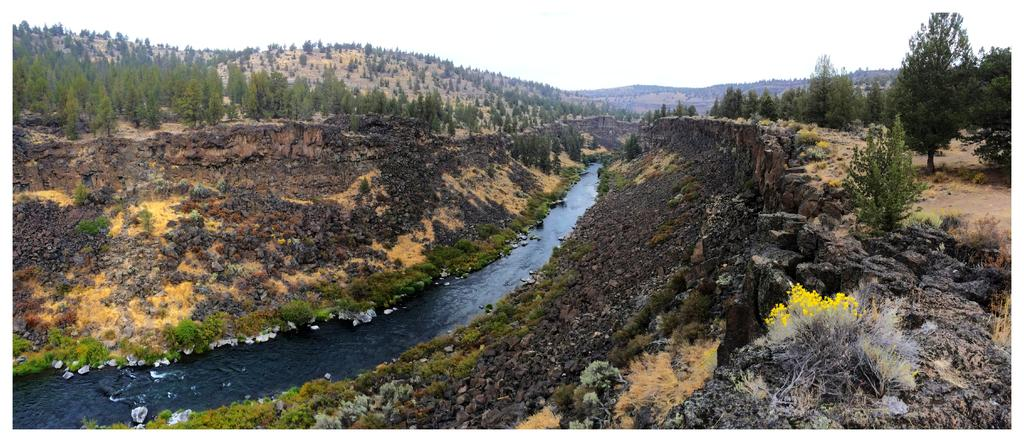What is the primary element in the image? There is water in the image. What types of vegetation can be seen in the image? There are plants, flowers, and trees in the image. What can be seen in the background of the image? There are hills and the sky visible in the background of the image. What type of wheel can be seen in the image? There is no wheel present in the image. What story is being told through the image? The image does not tell a story; it is a visual representation of water, plants, flowers, trees, hills, and the sky. 